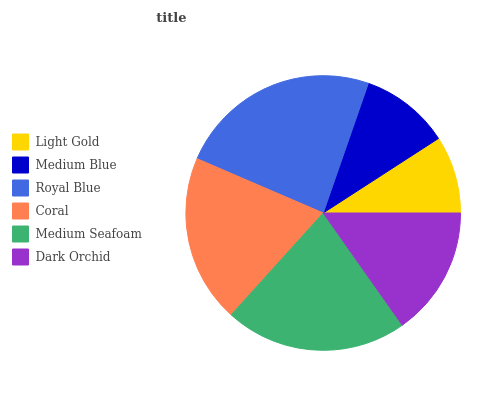Is Light Gold the minimum?
Answer yes or no. Yes. Is Royal Blue the maximum?
Answer yes or no. Yes. Is Medium Blue the minimum?
Answer yes or no. No. Is Medium Blue the maximum?
Answer yes or no. No. Is Medium Blue greater than Light Gold?
Answer yes or no. Yes. Is Light Gold less than Medium Blue?
Answer yes or no. Yes. Is Light Gold greater than Medium Blue?
Answer yes or no. No. Is Medium Blue less than Light Gold?
Answer yes or no. No. Is Coral the high median?
Answer yes or no. Yes. Is Dark Orchid the low median?
Answer yes or no. Yes. Is Medium Seafoam the high median?
Answer yes or no. No. Is Medium Seafoam the low median?
Answer yes or no. No. 